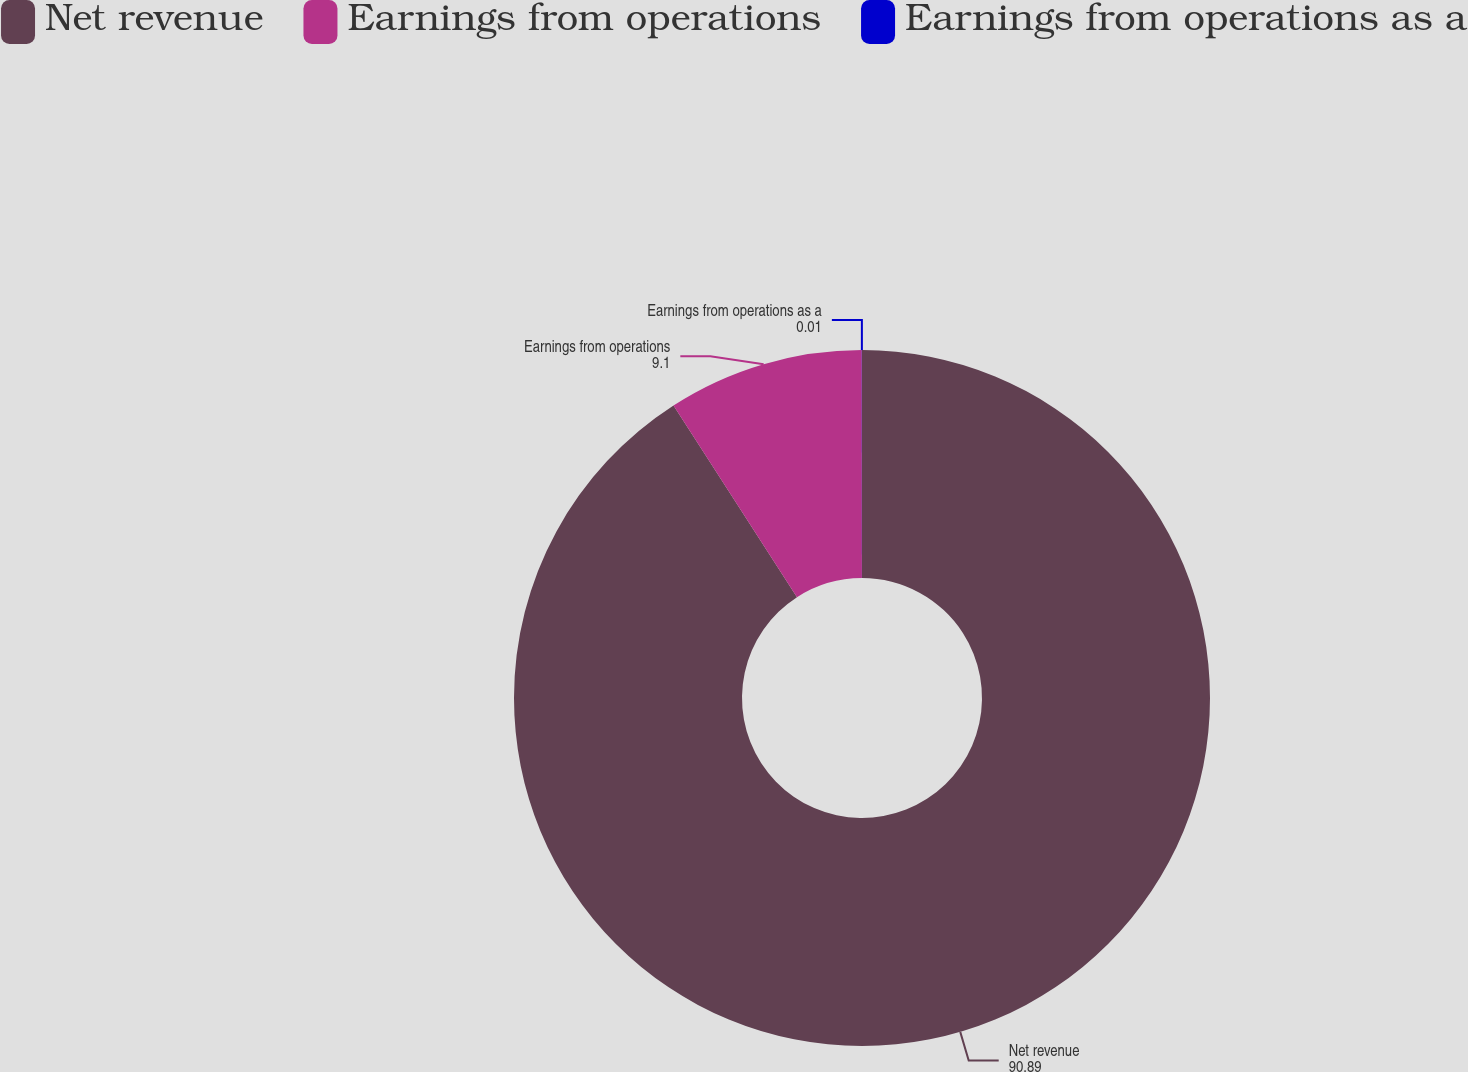<chart> <loc_0><loc_0><loc_500><loc_500><pie_chart><fcel>Net revenue<fcel>Earnings from operations<fcel>Earnings from operations as a<nl><fcel>90.89%<fcel>9.1%<fcel>0.01%<nl></chart> 